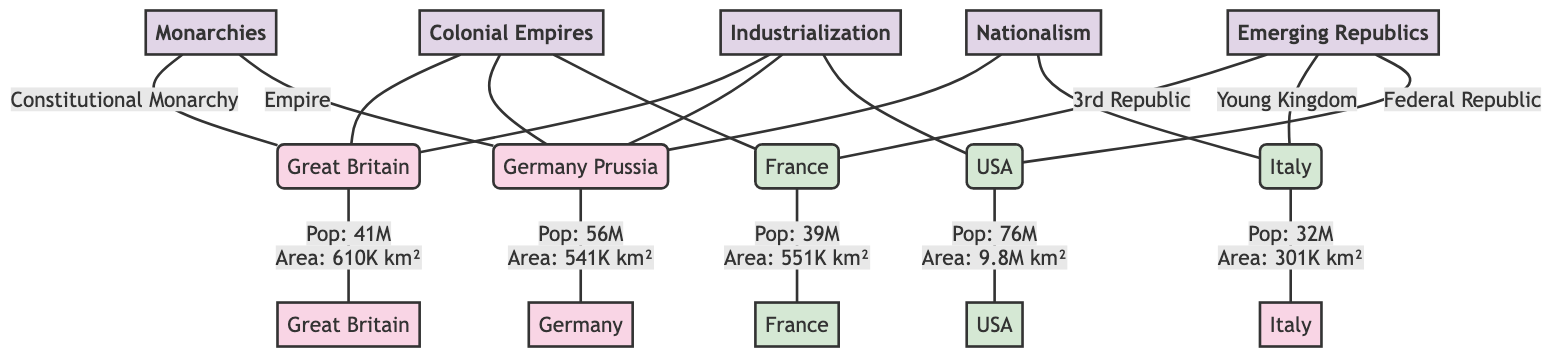What type of monarchy is Great Britain classified as? The diagram explicitly labels Great Britain as a "Constitutional Monarchy." Therefore, by following the connection from the node for Great Britain (B) to the category "Monarchies" (A), we discern that it falls under this classification.
Answer: Constitutional Monarchy What is the population of Germany? The node representing Germany (C) contains the statistic "Pop: 56M." This is clearly stated adjacent to the Germany node, allowing for a straightforward answer.
Answer: 56M How many emerging republics are depicted in the diagram? The diagram shows three nodes under the "Emerging Republics" category, labeled E (France), F (Italy), and G (USA). By counting these nodes, it's clear that there are three emerging republics represented.
Answer: 3 What common factor links Great Britain, Germany, and France? The diagram indicates a "Colonial Empires" connection that branches out to Great Britain (B), Germany (C), and France (E). Each of these three nodes branches from the "Colonial Empires" node (M), evidencing a shared linkage to colonial pursuits.
Answer: Colonial Empires Which republic has the largest area according to the diagram? The node for the USA (G) states "Area: 9.8M km²," which is greater compared to the areas of France (E, 551K km²) and Italy (F, 301K km²). Comparing these values, the USA has the largest area among the republics shown.
Answer: 9.8M km² What category does nationalism link with in the diagram? The diagram connects nationalism (O) to Germany (C) and Italy (F) through a direct line, indicating that these two states are linked by the concept of nationalism. To find the answer, one can follow the connections from the nationalism node to each corresponding country node.
Answer: Germany and Italy What is the population of Italy? The node representing Italy (F) contains the information "Pop: 32M," which is directly visible next to the Italy label. Thus, retrieving the population is straightforward based on the diagram's content.
Answer: 32M How many nodes are classified as monarchies? The diagram shows two nodes under the "Monarchies" category (B for Great Britain and C for Germany). By counting these nodes, we find there are a total of two monarchies represented.
Answer: 2 What type of government does the USA represent in this diagram? The USA (G) is classified under the emerging republics category, as indicated directly in its placement. Thus, identifying the type of government requires recognizing it solely as part of the emerging republics grouping.
Answer: Federal Republic 